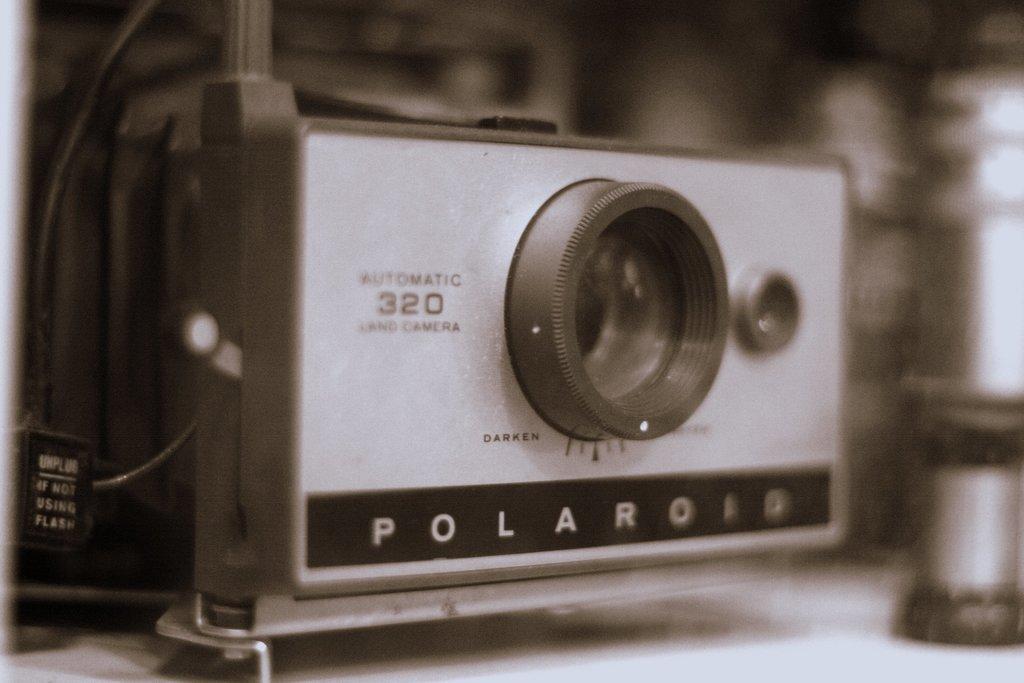Could you give a brief overview of what you see in this image? In this image, we can see a camera with lens. On the left side, we can see some wire. Background there is a blur view. 